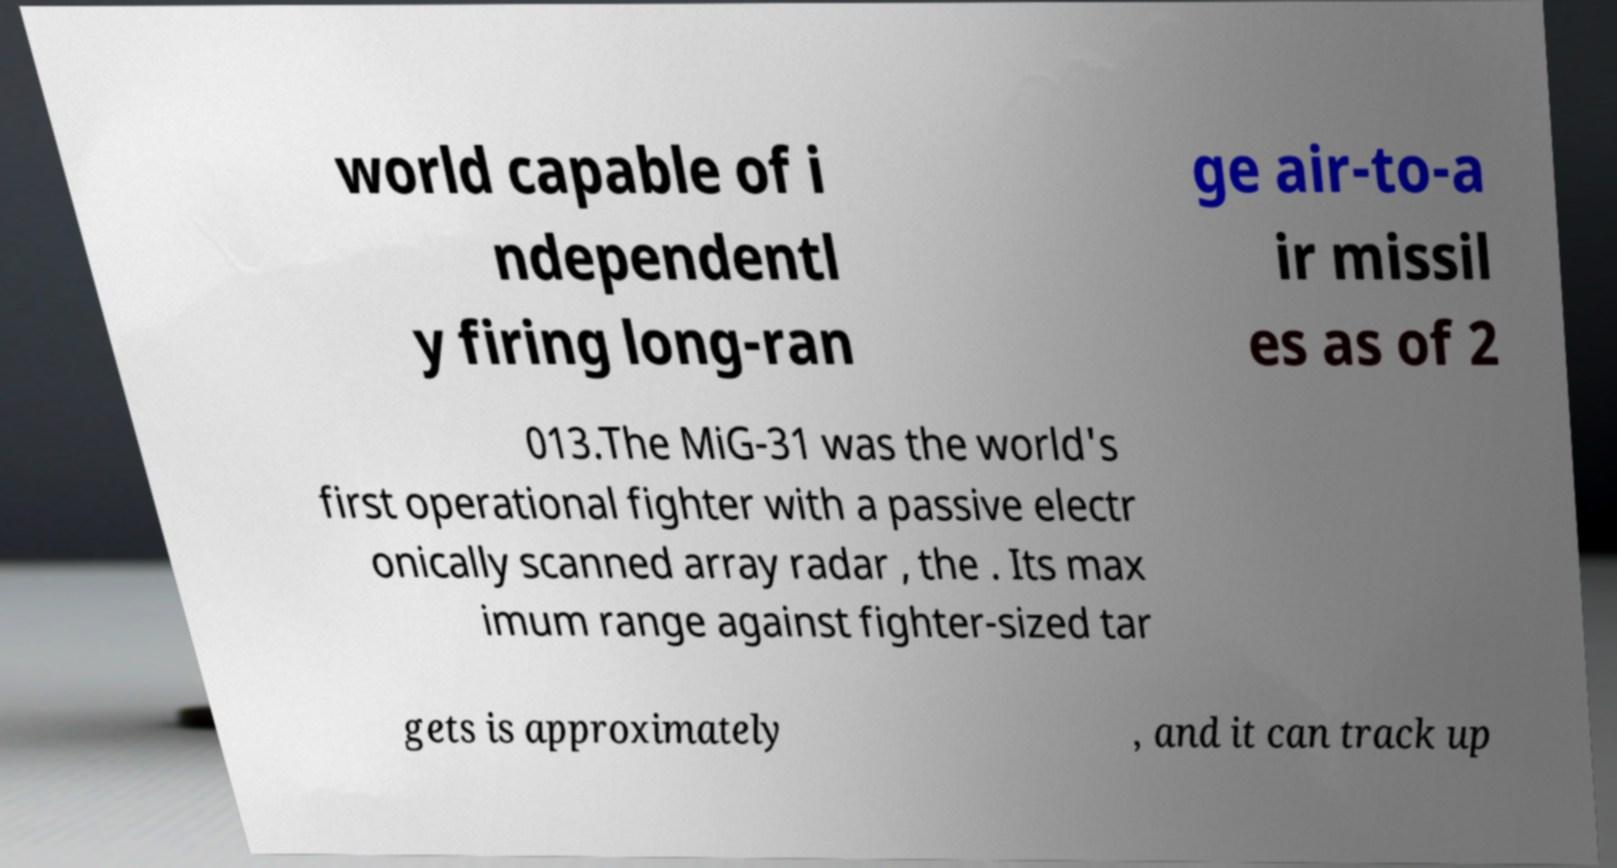Could you assist in decoding the text presented in this image and type it out clearly? world capable of i ndependentl y firing long-ran ge air-to-a ir missil es as of 2 013.The MiG-31 was the world's first operational fighter with a passive electr onically scanned array radar , the . Its max imum range against fighter-sized tar gets is approximately , and it can track up 